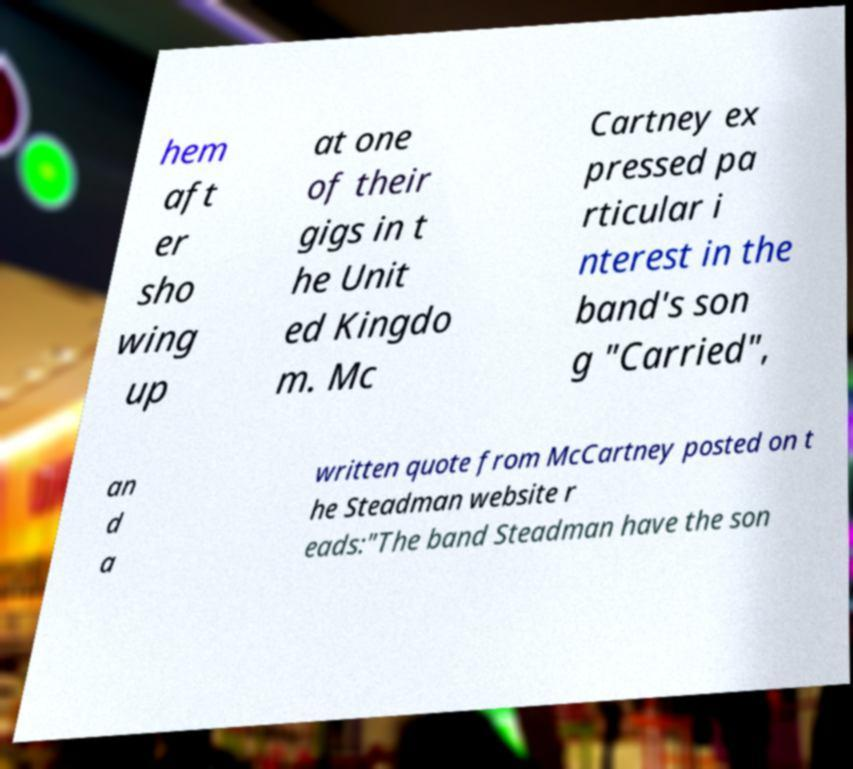There's text embedded in this image that I need extracted. Can you transcribe it verbatim? hem aft er sho wing up at one of their gigs in t he Unit ed Kingdo m. Mc Cartney ex pressed pa rticular i nterest in the band's son g "Carried", an d a written quote from McCartney posted on t he Steadman website r eads:"The band Steadman have the son 